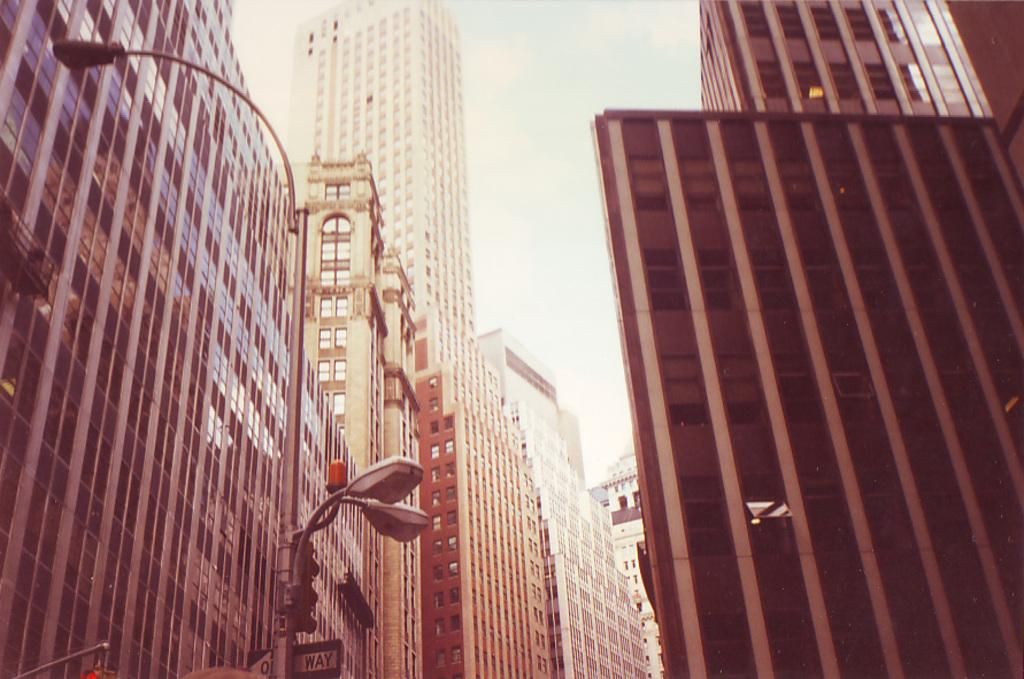<image>
Render a clear and concise summary of the photo. A one way sign is partially covered by a street light. 